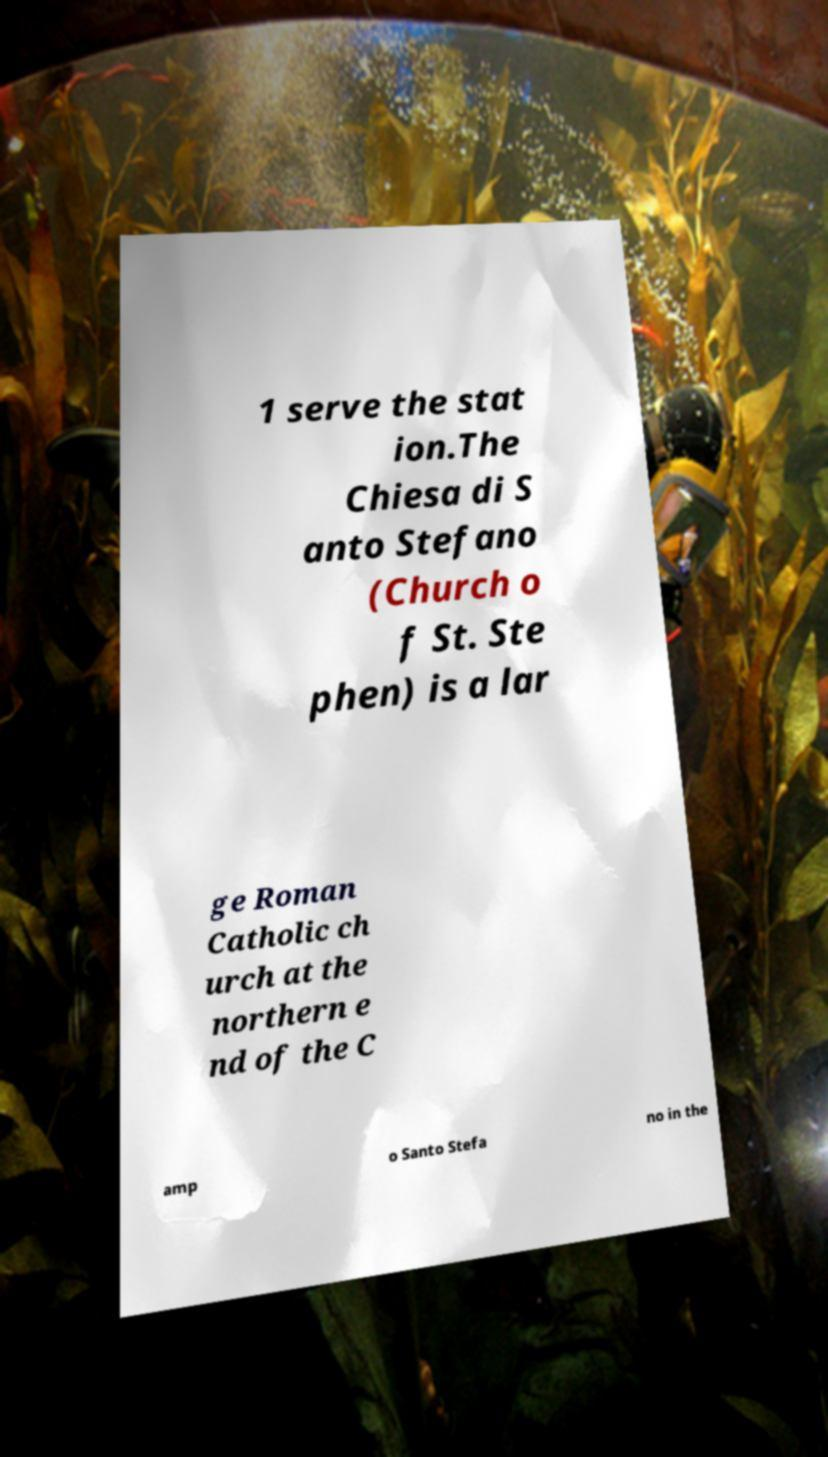Could you extract and type out the text from this image? 1 serve the stat ion.The Chiesa di S anto Stefano (Church o f St. Ste phen) is a lar ge Roman Catholic ch urch at the northern e nd of the C amp o Santo Stefa no in the 